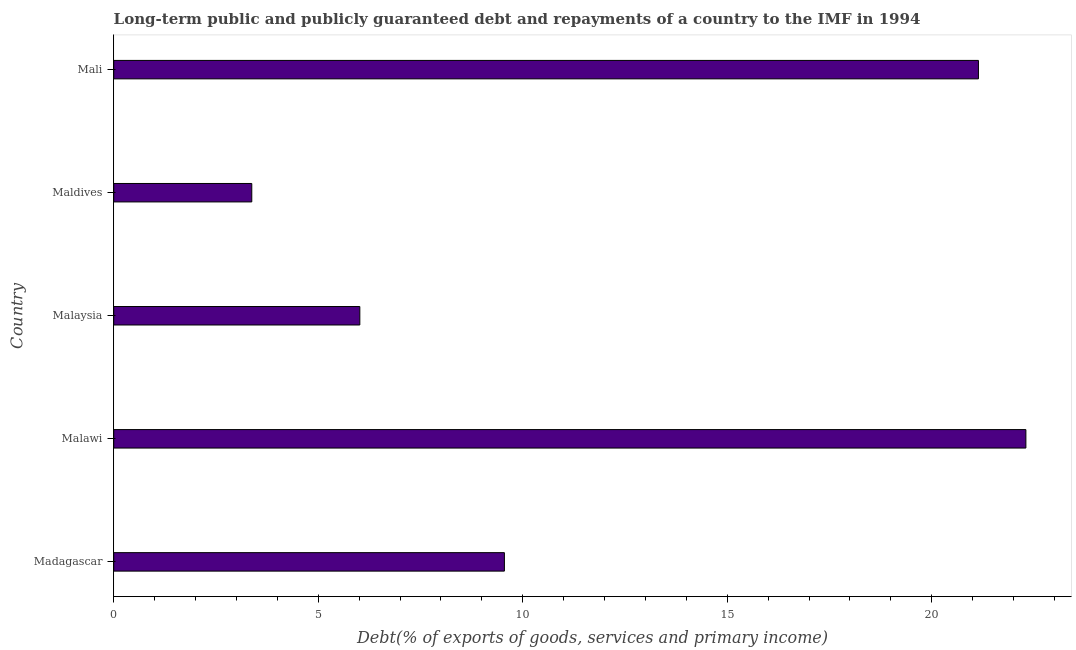Does the graph contain any zero values?
Your response must be concise. No. What is the title of the graph?
Your answer should be very brief. Long-term public and publicly guaranteed debt and repayments of a country to the IMF in 1994. What is the label or title of the X-axis?
Your response must be concise. Debt(% of exports of goods, services and primary income). What is the debt service in Mali?
Make the answer very short. 21.14. Across all countries, what is the maximum debt service?
Provide a short and direct response. 22.3. Across all countries, what is the minimum debt service?
Your response must be concise. 3.38. In which country was the debt service maximum?
Offer a very short reply. Malawi. In which country was the debt service minimum?
Give a very brief answer. Maldives. What is the sum of the debt service?
Your response must be concise. 62.39. What is the difference between the debt service in Malawi and Maldives?
Offer a very short reply. 18.93. What is the average debt service per country?
Your answer should be very brief. 12.48. What is the median debt service?
Your answer should be compact. 9.55. What is the ratio of the debt service in Madagascar to that in Maldives?
Provide a succinct answer. 2.83. Is the debt service in Madagascar less than that in Mali?
Your answer should be very brief. Yes. What is the difference between the highest and the second highest debt service?
Your response must be concise. 1.16. Is the sum of the debt service in Madagascar and Mali greater than the maximum debt service across all countries?
Your answer should be compact. Yes. What is the difference between the highest and the lowest debt service?
Your answer should be very brief. 18.93. Are all the bars in the graph horizontal?
Offer a terse response. Yes. Are the values on the major ticks of X-axis written in scientific E-notation?
Your response must be concise. No. What is the Debt(% of exports of goods, services and primary income) of Madagascar?
Keep it short and to the point. 9.55. What is the Debt(% of exports of goods, services and primary income) in Malawi?
Ensure brevity in your answer.  22.3. What is the Debt(% of exports of goods, services and primary income) in Malaysia?
Keep it short and to the point. 6.02. What is the Debt(% of exports of goods, services and primary income) of Maldives?
Provide a succinct answer. 3.38. What is the Debt(% of exports of goods, services and primary income) in Mali?
Your response must be concise. 21.14. What is the difference between the Debt(% of exports of goods, services and primary income) in Madagascar and Malawi?
Keep it short and to the point. -12.75. What is the difference between the Debt(% of exports of goods, services and primary income) in Madagascar and Malaysia?
Offer a terse response. 3.53. What is the difference between the Debt(% of exports of goods, services and primary income) in Madagascar and Maldives?
Offer a terse response. 6.18. What is the difference between the Debt(% of exports of goods, services and primary income) in Madagascar and Mali?
Provide a succinct answer. -11.59. What is the difference between the Debt(% of exports of goods, services and primary income) in Malawi and Malaysia?
Your answer should be compact. 16.29. What is the difference between the Debt(% of exports of goods, services and primary income) in Malawi and Maldives?
Keep it short and to the point. 18.93. What is the difference between the Debt(% of exports of goods, services and primary income) in Malawi and Mali?
Your answer should be very brief. 1.16. What is the difference between the Debt(% of exports of goods, services and primary income) in Malaysia and Maldives?
Your response must be concise. 2.64. What is the difference between the Debt(% of exports of goods, services and primary income) in Malaysia and Mali?
Your answer should be very brief. -15.13. What is the difference between the Debt(% of exports of goods, services and primary income) in Maldives and Mali?
Ensure brevity in your answer.  -17.77. What is the ratio of the Debt(% of exports of goods, services and primary income) in Madagascar to that in Malawi?
Keep it short and to the point. 0.43. What is the ratio of the Debt(% of exports of goods, services and primary income) in Madagascar to that in Malaysia?
Keep it short and to the point. 1.59. What is the ratio of the Debt(% of exports of goods, services and primary income) in Madagascar to that in Maldives?
Your response must be concise. 2.83. What is the ratio of the Debt(% of exports of goods, services and primary income) in Madagascar to that in Mali?
Give a very brief answer. 0.45. What is the ratio of the Debt(% of exports of goods, services and primary income) in Malawi to that in Malaysia?
Your answer should be compact. 3.71. What is the ratio of the Debt(% of exports of goods, services and primary income) in Malawi to that in Maldives?
Your response must be concise. 6.61. What is the ratio of the Debt(% of exports of goods, services and primary income) in Malawi to that in Mali?
Your response must be concise. 1.05. What is the ratio of the Debt(% of exports of goods, services and primary income) in Malaysia to that in Maldives?
Keep it short and to the point. 1.78. What is the ratio of the Debt(% of exports of goods, services and primary income) in Malaysia to that in Mali?
Provide a short and direct response. 0.28. What is the ratio of the Debt(% of exports of goods, services and primary income) in Maldives to that in Mali?
Offer a very short reply. 0.16. 